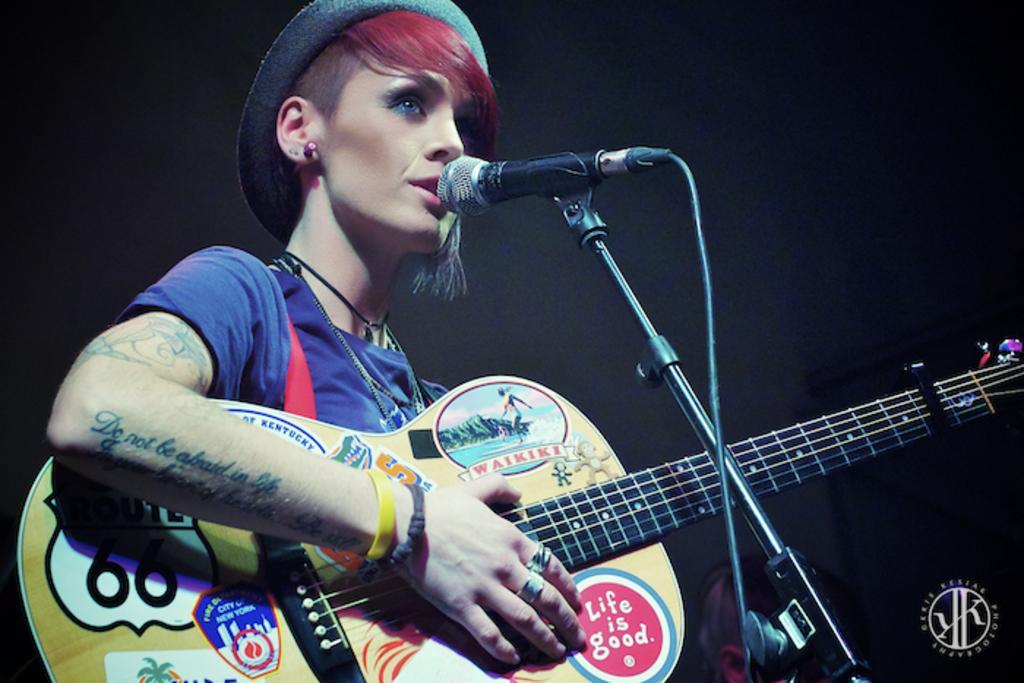Can you describe this image briefly? In this image a lady is singing in front of her there is a mic. She is wearing blue t-shirt and a hat. She is playing guitar. The background is dark. 